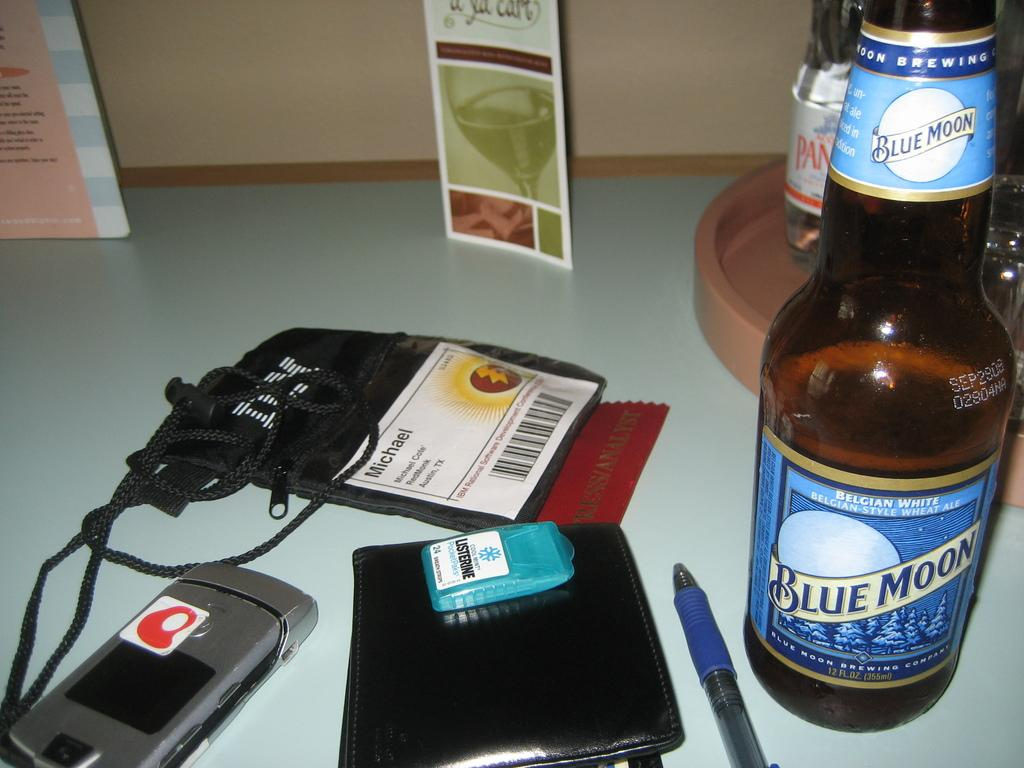<image>
Describe the image concisely. A bottle of Blue Moon beer sits on a desk near a wallet. 